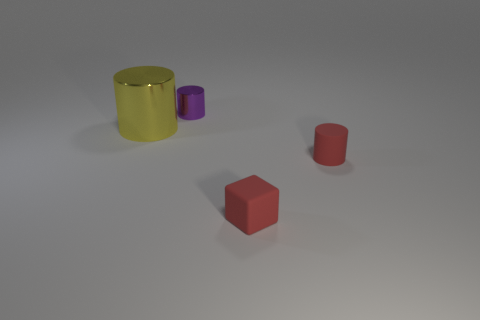What number of things are either tiny rubber spheres or tiny metallic cylinders?
Your response must be concise. 1. Is the shape of the large yellow metal object the same as the metallic object that is to the right of the yellow cylinder?
Give a very brief answer. Yes. What is the shape of the metal thing left of the small metallic thing?
Provide a succinct answer. Cylinder. Is the tiny purple metallic thing the same shape as the large metal thing?
Keep it short and to the point. Yes. What is the size of the red thing that is the same shape as the purple object?
Your answer should be very brief. Small. There is a red matte thing left of the red cylinder; is its size the same as the large yellow cylinder?
Make the answer very short. No. How big is the thing that is behind the cube and to the right of the tiny purple metallic cylinder?
Ensure brevity in your answer.  Small. There is a block that is the same color as the matte cylinder; what material is it?
Your response must be concise. Rubber. What number of small metal things have the same color as the small rubber block?
Your answer should be very brief. 0. Are there an equal number of big cylinders that are on the right side of the small shiny thing and tiny purple metal cylinders?
Offer a very short reply. No. 